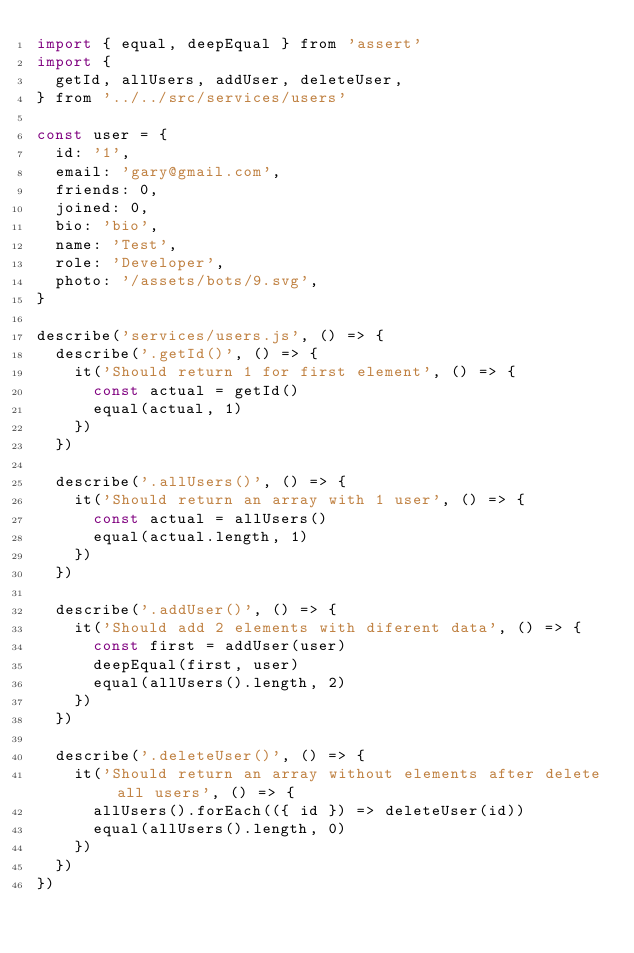Convert code to text. <code><loc_0><loc_0><loc_500><loc_500><_JavaScript_>import { equal, deepEqual } from 'assert'
import {
  getId, allUsers, addUser, deleteUser,
} from '../../src/services/users'

const user = {
  id: '1',
  email: 'gary@gmail.com',
  friends: 0,
  joined: 0,
  bio: 'bio',
  name: 'Test',
  role: 'Developer',
  photo: '/assets/bots/9.svg',
}

describe('services/users.js', () => {
  describe('.getId()', () => {
    it('Should return 1 for first element', () => {
      const actual = getId()
      equal(actual, 1)
    })
  })

  describe('.allUsers()', () => {
    it('Should return an array with 1 user', () => {
      const actual = allUsers()
      equal(actual.length, 1)
    })
  })

  describe('.addUser()', () => {
    it('Should add 2 elements with diferent data', () => {
      const first = addUser(user)
      deepEqual(first, user)
      equal(allUsers().length, 2)
    })
  })

  describe('.deleteUser()', () => {
    it('Should return an array without elements after delete all users', () => {
      allUsers().forEach(({ id }) => deleteUser(id))
      equal(allUsers().length, 0)
    })
  })
})
</code> 